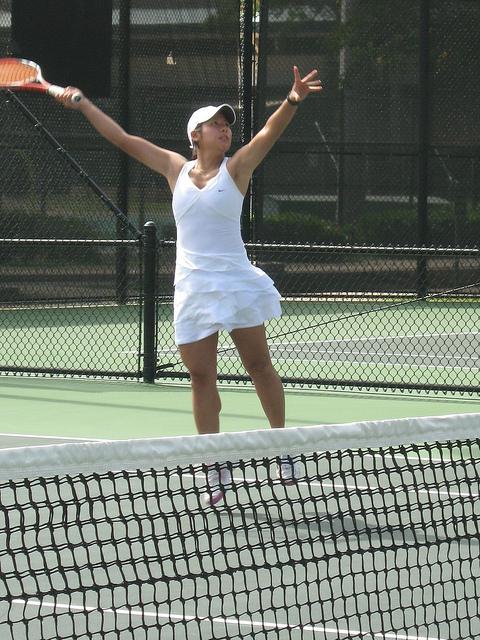Are they playing tennis?
Give a very brief answer. Yes. What color is her outfit?
Quick response, please. White. Is she wearing a skirt?
Keep it brief. Yes. 